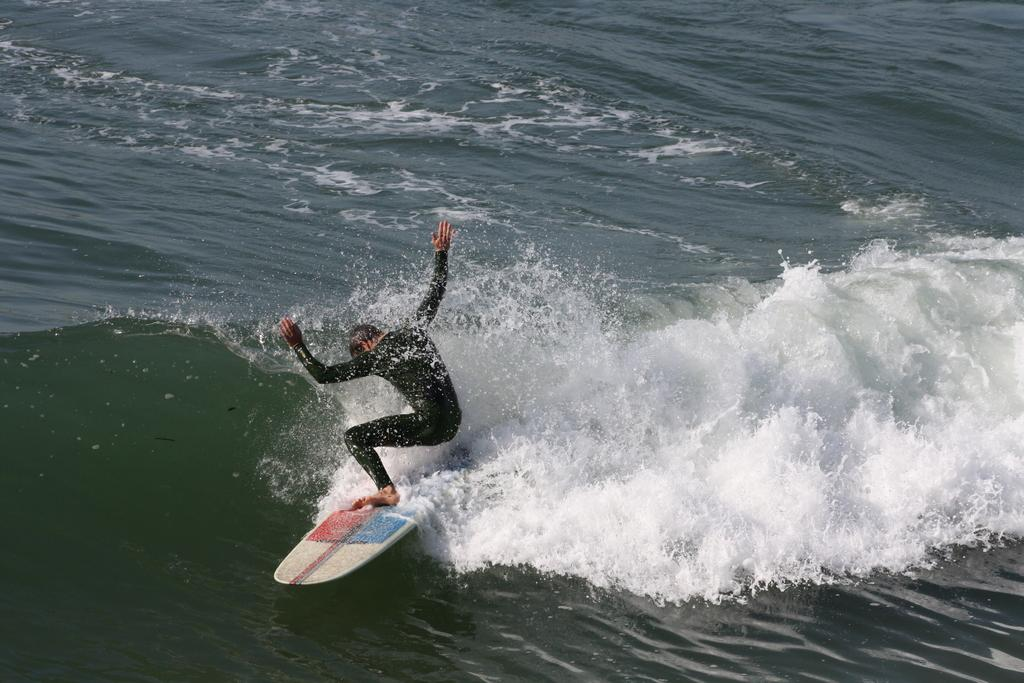What is the person in the image doing? The person is doing surfboarding. Where is the surfboarding taking place? The surfboarding is taking place on water. Can you see any jellyfish in the water while the person is surfboarding? There is no mention of jellyfish in the image, so it cannot be determined if any are present. Is the person surfboarding on a mountain in the image? No, the person is surfboarding on water, not on a mountain. Is there a plane visible in the image while the person is surfboarding? There is no mention of a plane in the image, so it cannot be determined if one is present. 